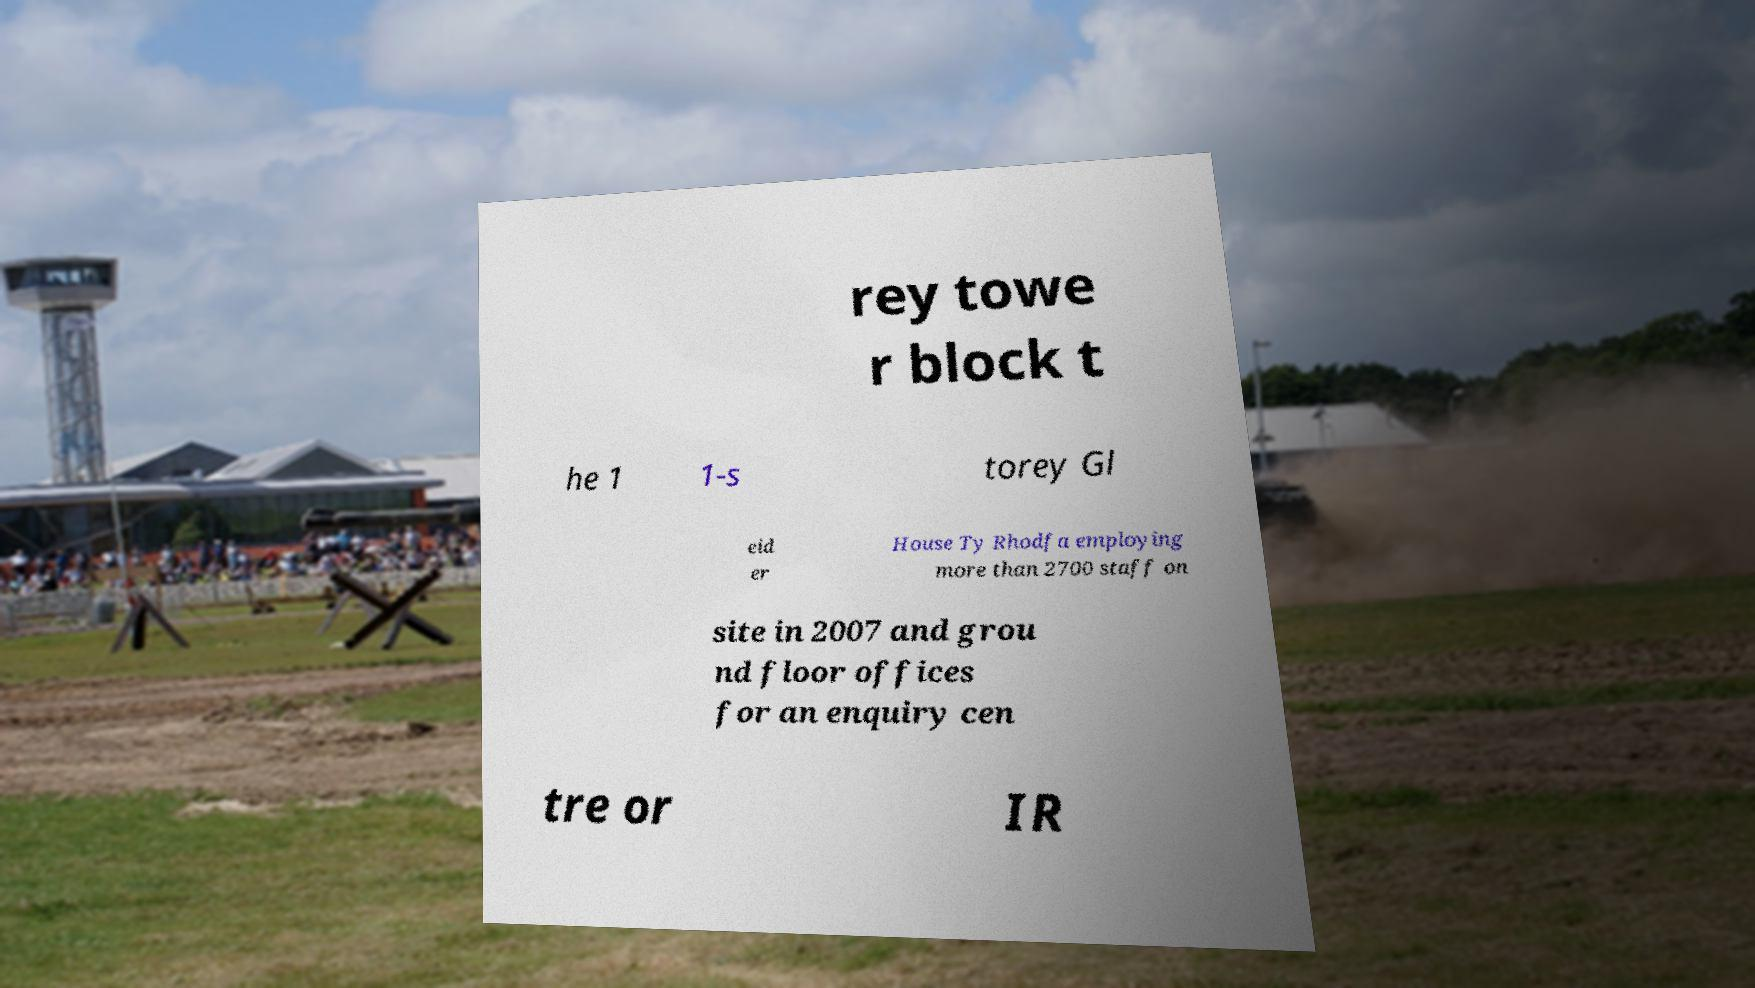Could you assist in decoding the text presented in this image and type it out clearly? rey towe r block t he 1 1-s torey Gl eid er House Ty Rhodfa employing more than 2700 staff on site in 2007 and grou nd floor offices for an enquiry cen tre or IR 